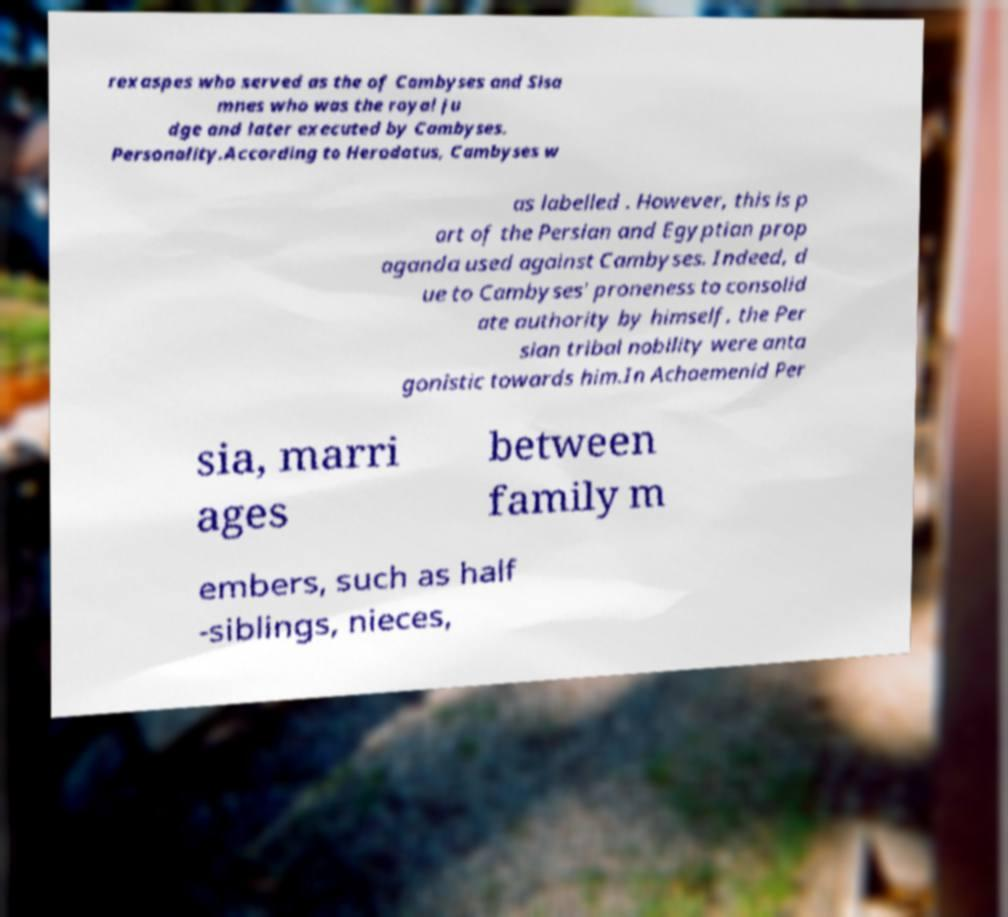Please identify and transcribe the text found in this image. rexaspes who served as the of Cambyses and Sisa mnes who was the royal ju dge and later executed by Cambyses. Personality.According to Herodotus, Cambyses w as labelled . However, this is p art of the Persian and Egyptian prop aganda used against Cambyses. Indeed, d ue to Cambyses' proneness to consolid ate authority by himself, the Per sian tribal nobility were anta gonistic towards him.In Achaemenid Per sia, marri ages between family m embers, such as half -siblings, nieces, 